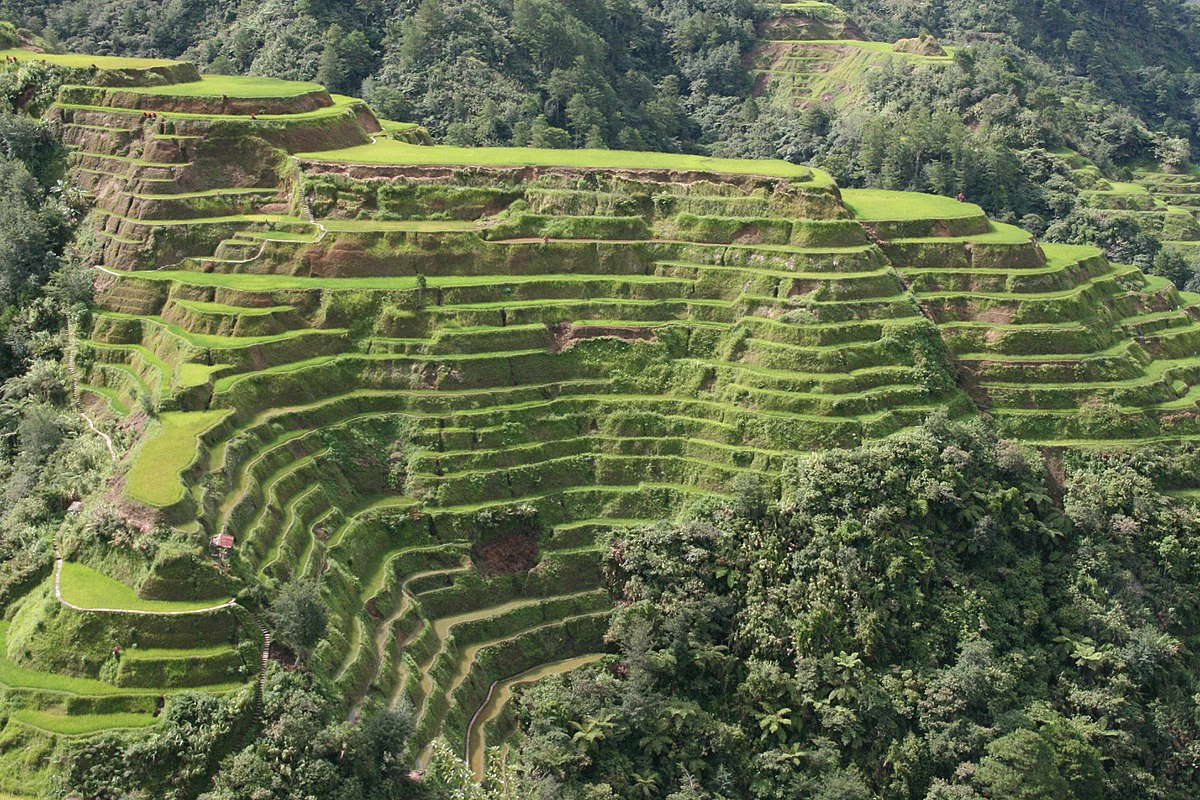Can you tell me more about the ecological significance of the Banaue Rice Terraces? The Banaue Rice Terraces play a crucial role in the local ecosystem. They help in preventing erosion by stabilizing the slopes, maintain local streams and rivers through intricate irrigation systems, and support a variety of wildlife, creating a microhabitat for numerous species of plants, insects, and birds. Their sustainable agricultural practices have minimized adverse impacts on the environment, making them a model of ecological farming that balances human needs with nature's parameters. 